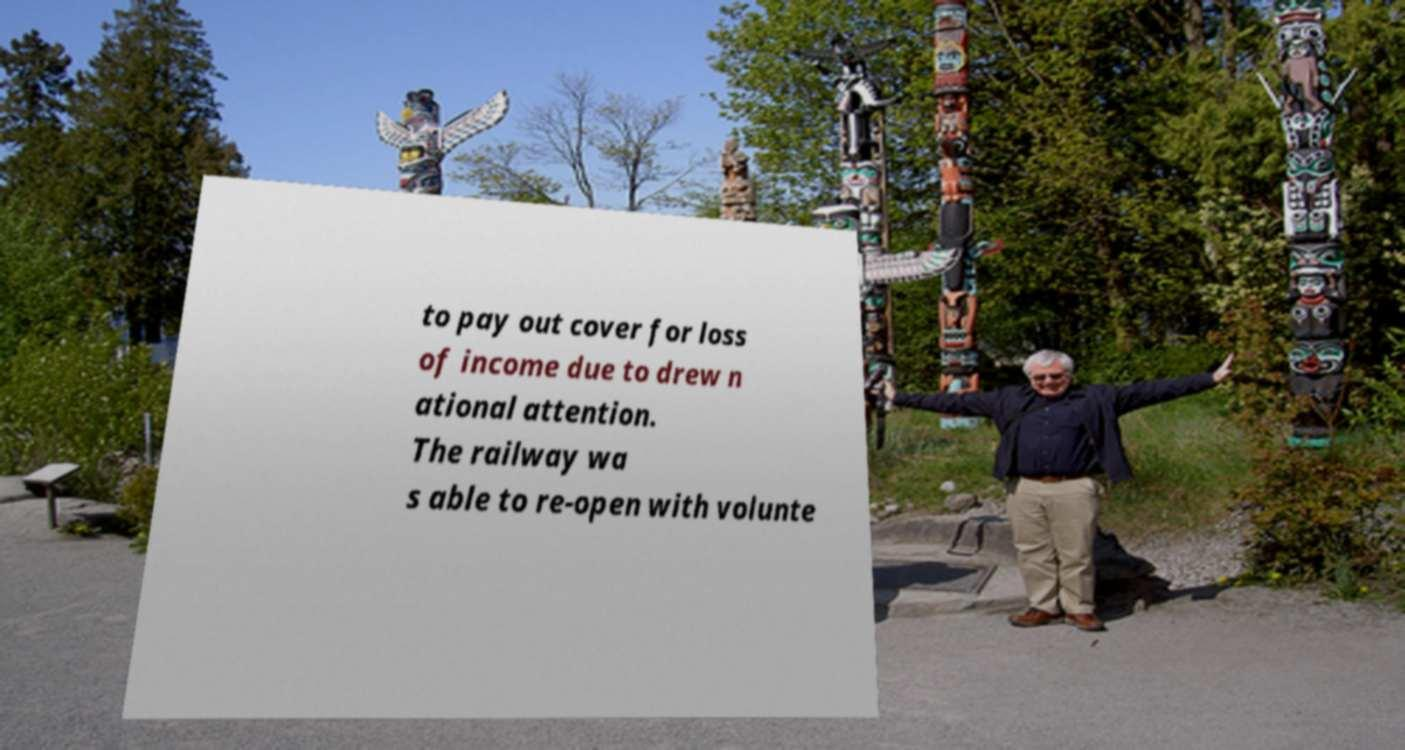Please identify and transcribe the text found in this image. to pay out cover for loss of income due to drew n ational attention. The railway wa s able to re-open with volunte 